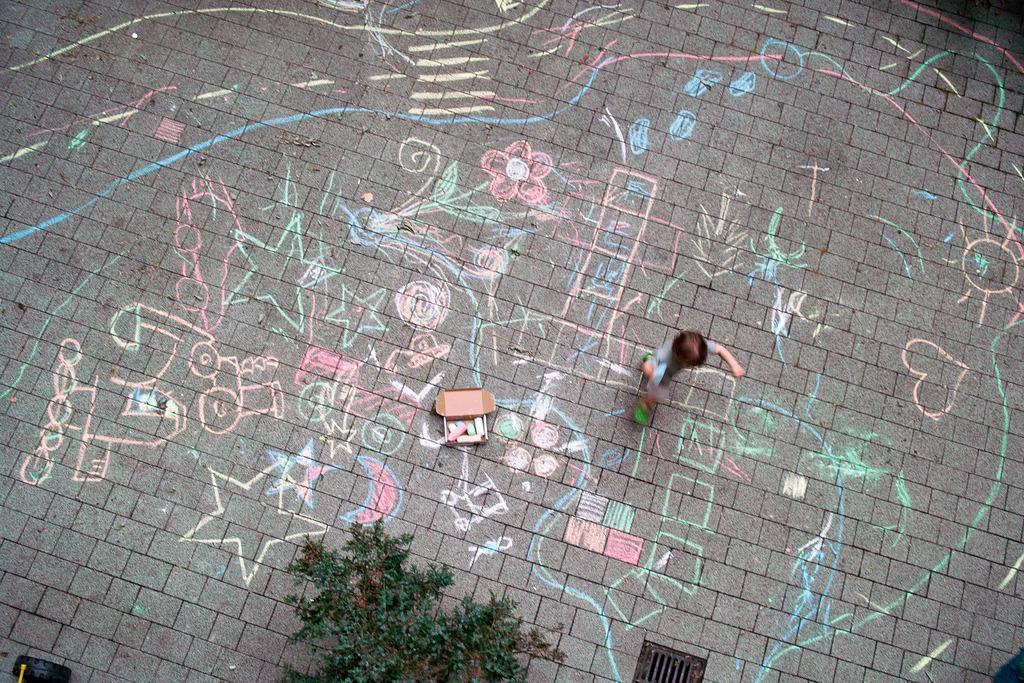Please provide a concise description of this image. In this image we can see a boy. We can also see the drawing on the surface with the choc pieces. Image also consists of a tyre, plant and also the manhole. 